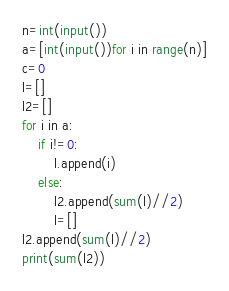<code> <loc_0><loc_0><loc_500><loc_500><_Python_>n=int(input())
a=[int(input())for i in range(n)]
c=0
l=[]
l2=[]
for i in a:
    if i!=0:
        l.append(i)
    else:
        l2.append(sum(l)//2)
        l=[]
l2.append(sum(l)//2)
print(sum(l2))</code> 